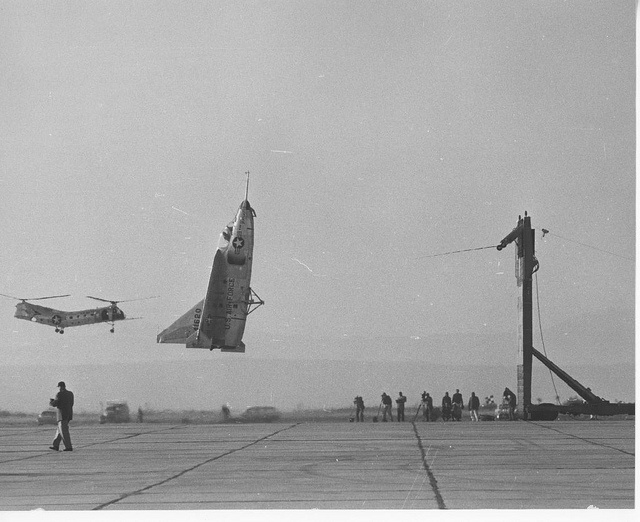Describe the objects in this image and their specific colors. I can see airplane in silver, gray, darkgray, black, and lightgray tones, people in silver, black, gray, darkgray, and lightgray tones, truck in gray, darkgray, lightgray, and silver tones, people in gray, darkgray, black, and silver tones, and people in gray, black, darkgray, and silver tones in this image. 